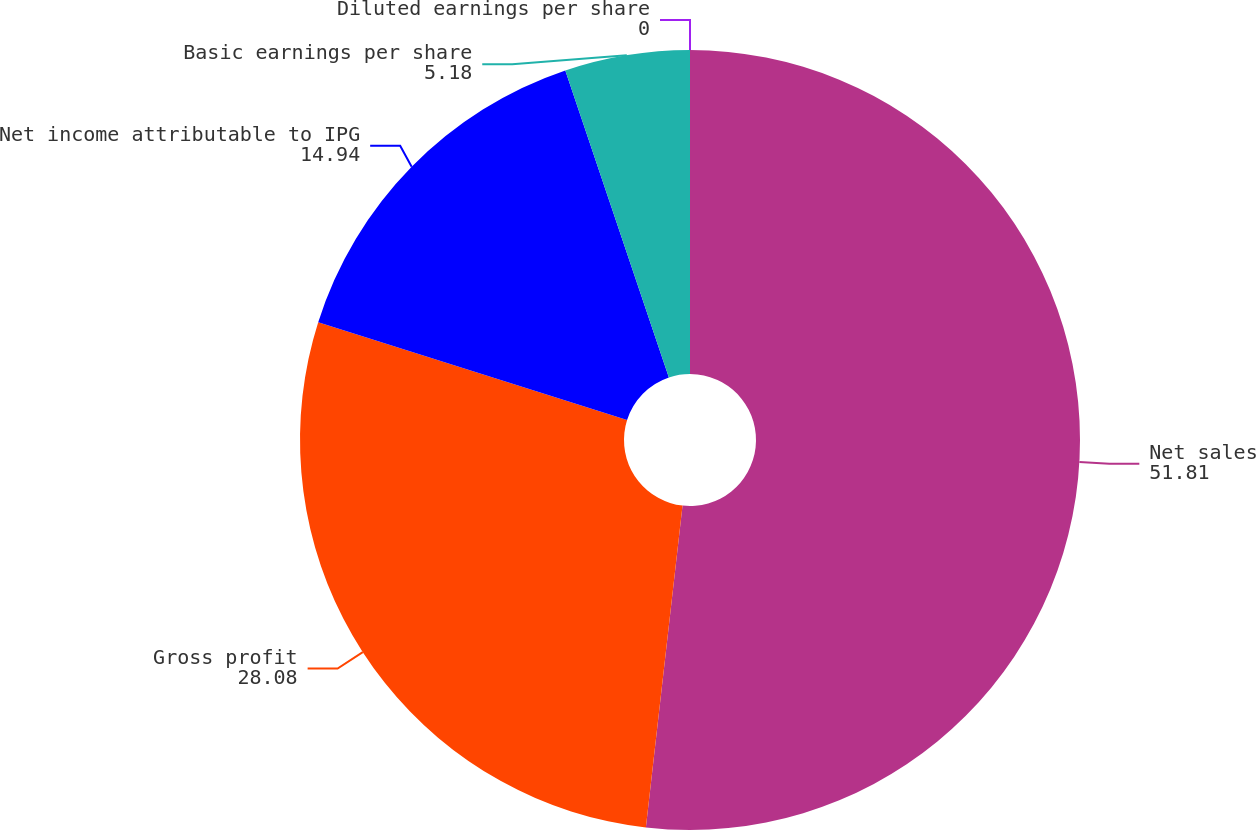<chart> <loc_0><loc_0><loc_500><loc_500><pie_chart><fcel>Net sales<fcel>Gross profit<fcel>Net income attributable to IPG<fcel>Basic earnings per share<fcel>Diluted earnings per share<nl><fcel>51.81%<fcel>28.08%<fcel>14.94%<fcel>5.18%<fcel>0.0%<nl></chart> 